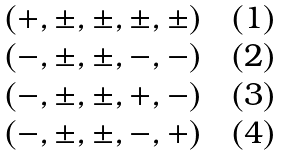Convert formula to latex. <formula><loc_0><loc_0><loc_500><loc_500>\begin{array} { l l l l } ( + , \pm , \pm , \pm , \pm ) \quad ( 1 ) \\ ( - , \pm , \pm , - , - ) \quad ( 2 ) \\ ( - , \pm , \pm , + , - ) \quad ( 3 ) \\ ( - , \pm , \pm , - , + ) \quad ( 4 ) \end{array}</formula> 